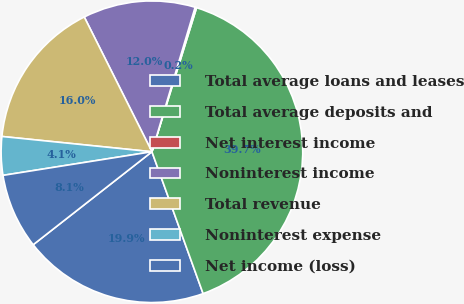Convert chart to OTSL. <chart><loc_0><loc_0><loc_500><loc_500><pie_chart><fcel>Total average loans and leases<fcel>Total average deposits and<fcel>Net interest income<fcel>Noninterest income<fcel>Total revenue<fcel>Noninterest expense<fcel>Net income (loss)<nl><fcel>19.94%<fcel>39.71%<fcel>0.16%<fcel>12.03%<fcel>15.98%<fcel>4.12%<fcel>8.07%<nl></chart> 